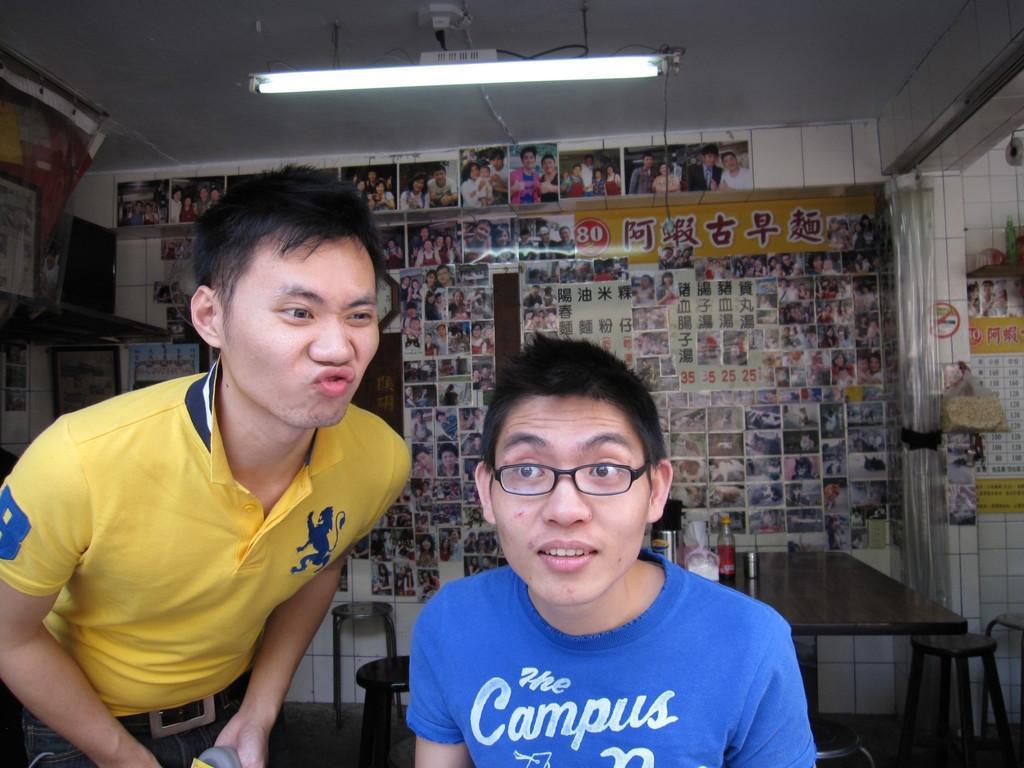How would you summarize this image in a sentence or two? In this image I can see two persons. There is table and a chair. At the background we can see a pictures on the wall. 